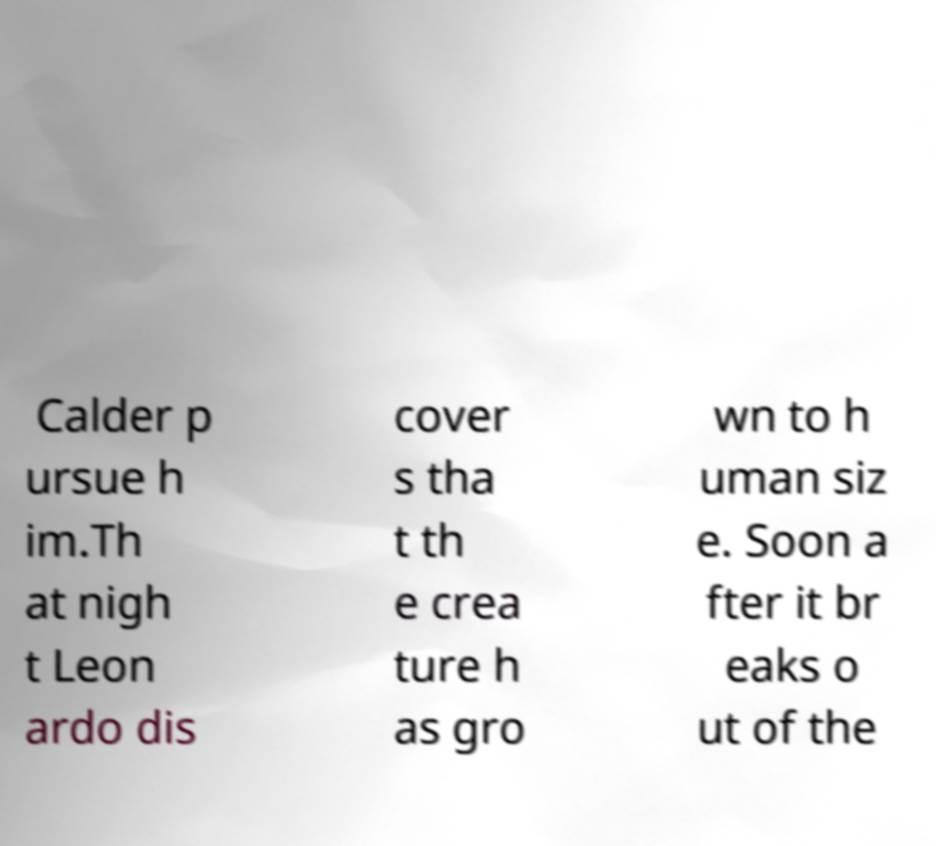There's text embedded in this image that I need extracted. Can you transcribe it verbatim? Calder p ursue h im.Th at nigh t Leon ardo dis cover s tha t th e crea ture h as gro wn to h uman siz e. Soon a fter it br eaks o ut of the 